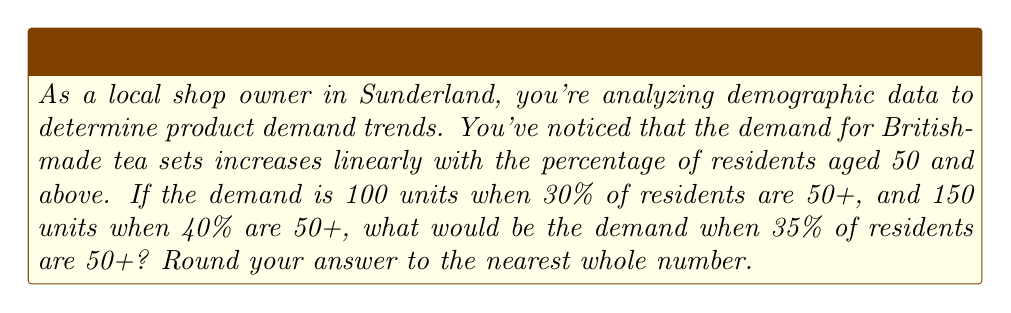Teach me how to tackle this problem. Let's approach this step-by-step using linear interpolation:

1) Let $x$ represent the percentage of residents aged 50+ and $y$ represent the demand for tea sets.

2) We have two known points:
   $(x_1, y_1) = (30, 100)$ and $(x_2, y_2) = (40, 150)$

3) The slope of the line can be calculated using:

   $$m = \frac{y_2 - y_1}{x_2 - x_1} = \frac{150 - 100}{40 - 30} = \frac{50}{10} = 5$$

4) We can use the point-slope form of a line:
   $y - y_1 = m(x - x_1)$

5) Substituting our known values:
   $y - 100 = 5(x - 30)$

6) Simplify:
   $y = 5x - 50$

7) Now, we want to find $y$ when $x = 35$:
   $y = 5(35) - 50 = 175 - 50 = 125$

Therefore, when 35% of residents are 50+, the demand would be 125 units.
Answer: 125 units 